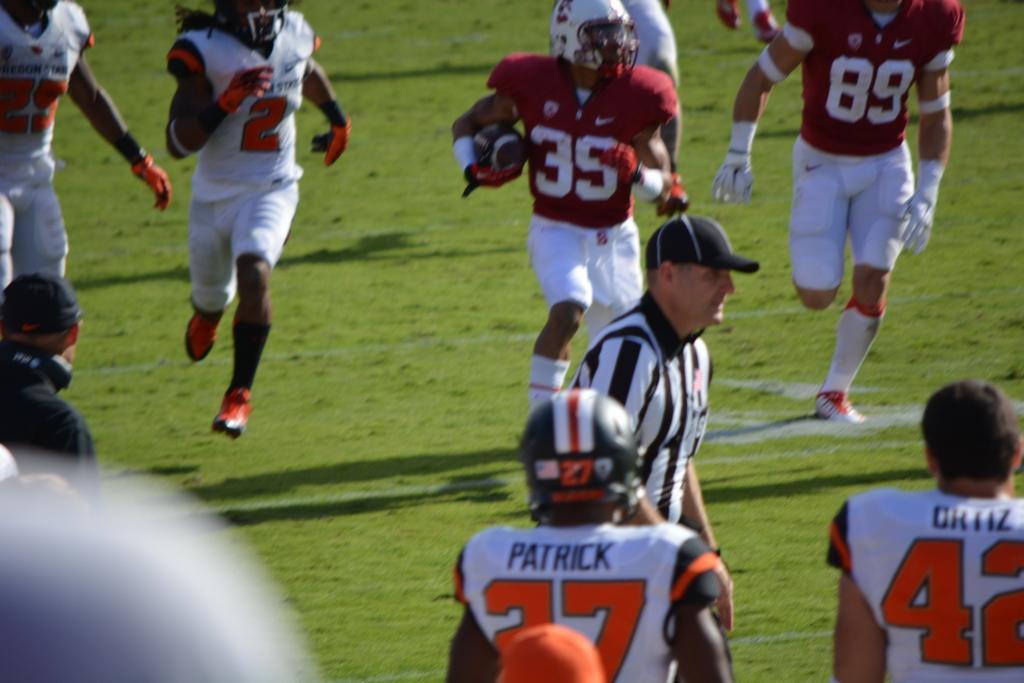Describe this image in one or two sentences. people are playing a game. in the center referee is standing. behind him a person is holding the ball. 